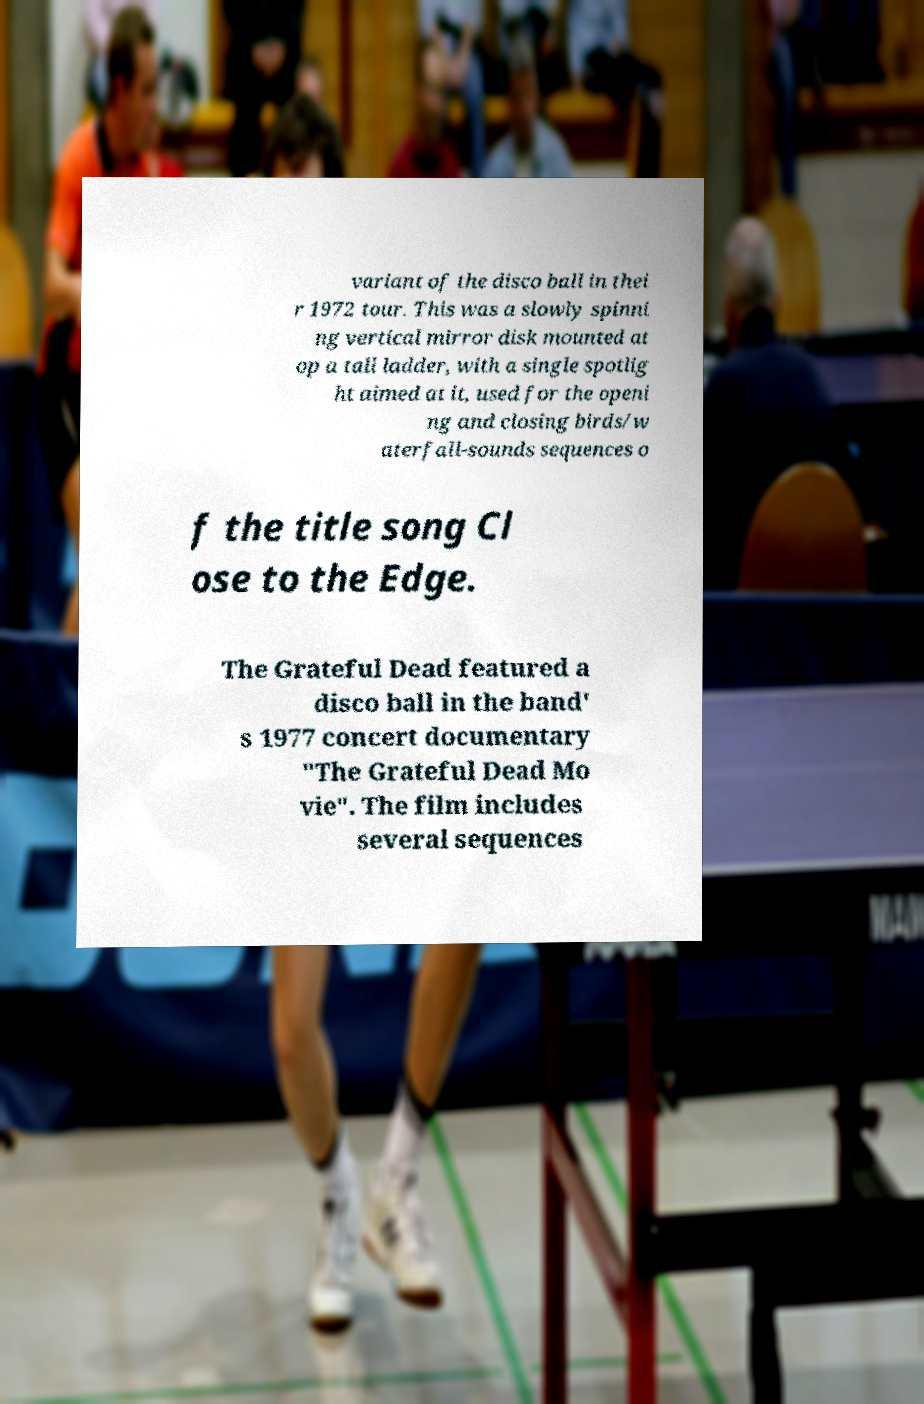I need the written content from this picture converted into text. Can you do that? variant of the disco ball in thei r 1972 tour. This was a slowly spinni ng vertical mirror disk mounted at op a tall ladder, with a single spotlig ht aimed at it, used for the openi ng and closing birds/w aterfall-sounds sequences o f the title song Cl ose to the Edge. The Grateful Dead featured a disco ball in the band' s 1977 concert documentary "The Grateful Dead Mo vie". The film includes several sequences 